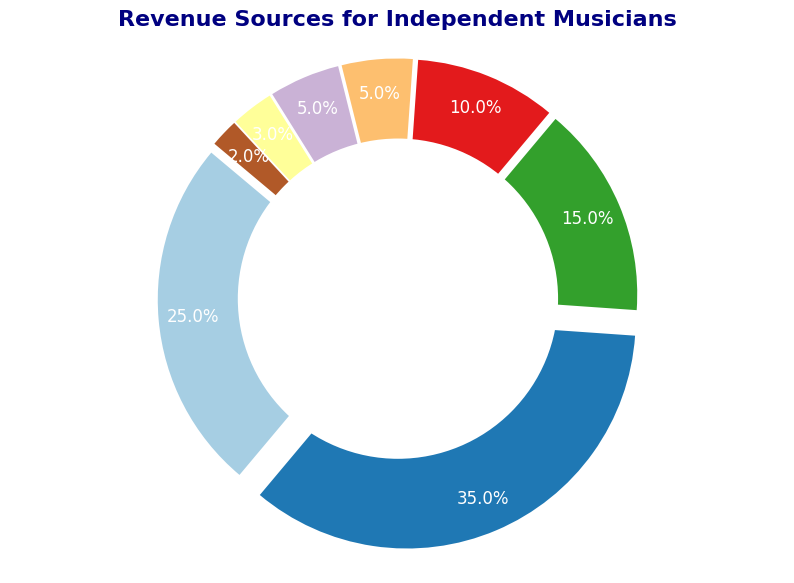What is the largest source of revenue for independent musicians? The pie chart shows the segment with the largest percentage. The "Live Performances" category has the largest segment with 35%.
Answer: Live Performances What is the combined revenue percentage from "Sponsorships," "Crowdfunding," and "Other"? Add the percentages from the "Sponsorships" (10%), "Crowdfunding" (5%), and "Other" (2%) categories: 10% + 5% + 2% = 17%.
Answer: 17% Which revenue source has the closest percentage to "Merchandise"? Compare the percentages of the revenue sources. Both "Crowdfunding" and "Digital Downloads" have the closest percentage to "Merchandise."
Answer: Crowdfunding and Digital Downloads What percentage of revenue comes from "Streaming" and "Sync Licensing" combined? Add the percentages of "Streaming" (25%) and "Sync Licensing" (3%): 25% + 3% = 28%.
Answer: 28% How much larger is the revenue percentage from "Live Performances" compared to "Merchandise"? Subtract the percentage of "Merchandise" (15%) from "Live Performances" (35%): 35% - 15% = 20%.
Answer: 20% What is the total percentage of revenue coming from non-performance sources (excluding "Live Performances")? Sum the percentages of all categories except "Live Performances" (35%): Streaming (25%), Merchandise (15%), Sponsorships (10%), Crowdfunding (5%), Digital Downloads (5%), Sync Licensing (3%), Other (2%). 25% + 15% + 10% + 5% + 5% + 3% + 2% = 65%.
Answer: 65% Which category has the smallest revenue percentage? Identify the segment with the smallest percentage. "Other" has the smallest percentage with 2%.
Answer: Other 